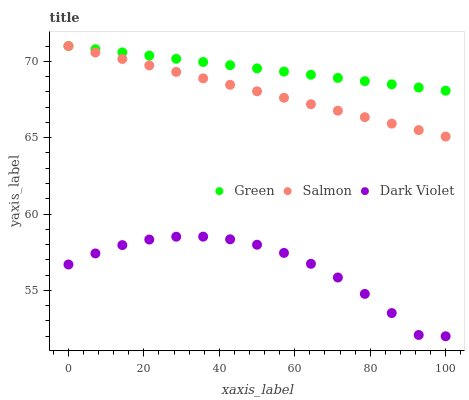Does Dark Violet have the minimum area under the curve?
Answer yes or no. Yes. Does Green have the maximum area under the curve?
Answer yes or no. Yes. Does Green have the minimum area under the curve?
Answer yes or no. No. Does Dark Violet have the maximum area under the curve?
Answer yes or no. No. Is Green the smoothest?
Answer yes or no. Yes. Is Dark Violet the roughest?
Answer yes or no. Yes. Is Dark Violet the smoothest?
Answer yes or no. No. Is Green the roughest?
Answer yes or no. No. Does Dark Violet have the lowest value?
Answer yes or no. Yes. Does Green have the lowest value?
Answer yes or no. No. Does Green have the highest value?
Answer yes or no. Yes. Does Dark Violet have the highest value?
Answer yes or no. No. Is Dark Violet less than Green?
Answer yes or no. Yes. Is Green greater than Dark Violet?
Answer yes or no. Yes. Does Green intersect Salmon?
Answer yes or no. Yes. Is Green less than Salmon?
Answer yes or no. No. Is Green greater than Salmon?
Answer yes or no. No. Does Dark Violet intersect Green?
Answer yes or no. No. 